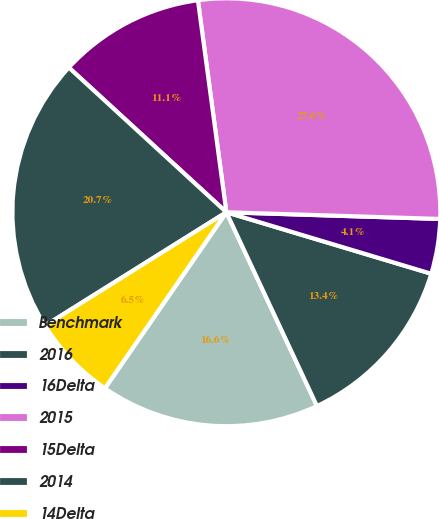Convert chart to OTSL. <chart><loc_0><loc_0><loc_500><loc_500><pie_chart><fcel>Benchmark<fcel>2016<fcel>16Delta<fcel>2015<fcel>15Delta<fcel>2014<fcel>14Delta<nl><fcel>16.57%<fcel>13.4%<fcel>4.14%<fcel>27.62%<fcel>11.05%<fcel>20.72%<fcel>6.49%<nl></chart> 